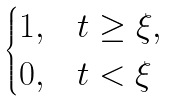Convert formula to latex. <formula><loc_0><loc_0><loc_500><loc_500>\begin{cases} 1 , & t \geq \xi , \\ 0 , & t < \xi \end{cases}</formula> 